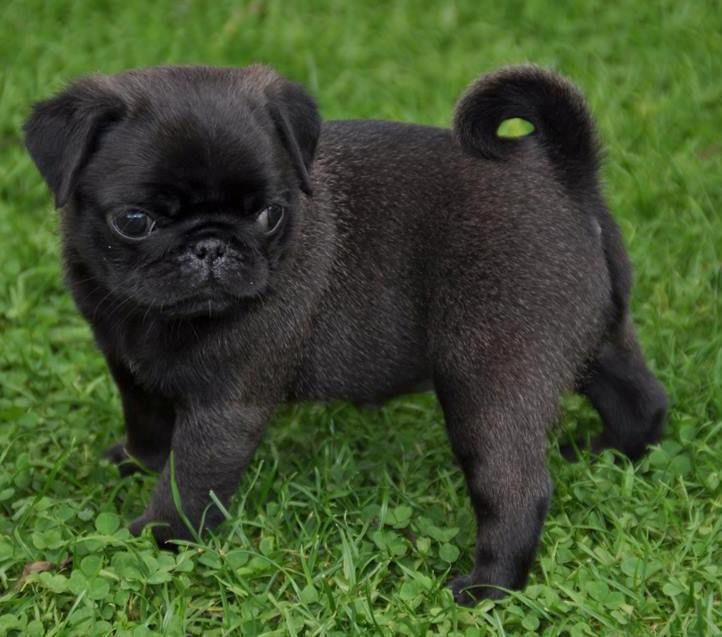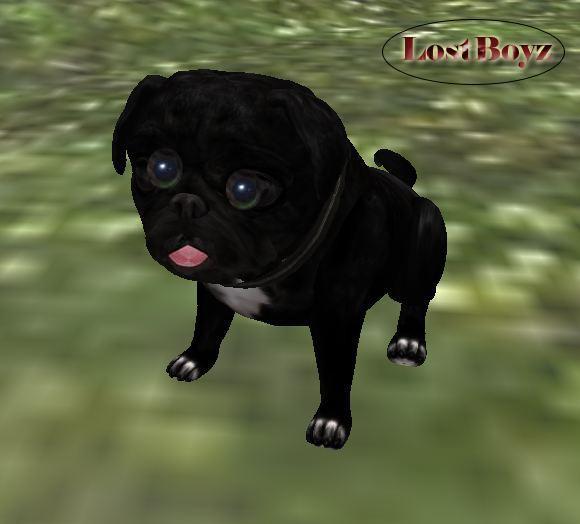The first image is the image on the left, the second image is the image on the right. Considering the images on both sides, is "The left image includes at least one black pug with something black-and-white grasped in its mouth." valid? Answer yes or no. No. The first image is the image on the left, the second image is the image on the right. Evaluate the accuracy of this statement regarding the images: "The left image contains at least one pug dog outside on grass chewing on an item.". Is it true? Answer yes or no. No. 